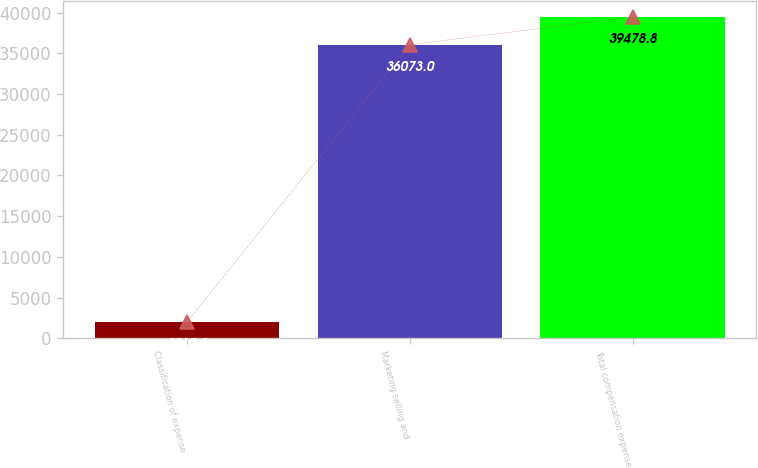Convert chart to OTSL. <chart><loc_0><loc_0><loc_500><loc_500><bar_chart><fcel>Classification of expense<fcel>Marketing selling and<fcel>Total compensation expense<nl><fcel>2015<fcel>36073<fcel>39478.8<nl></chart> 